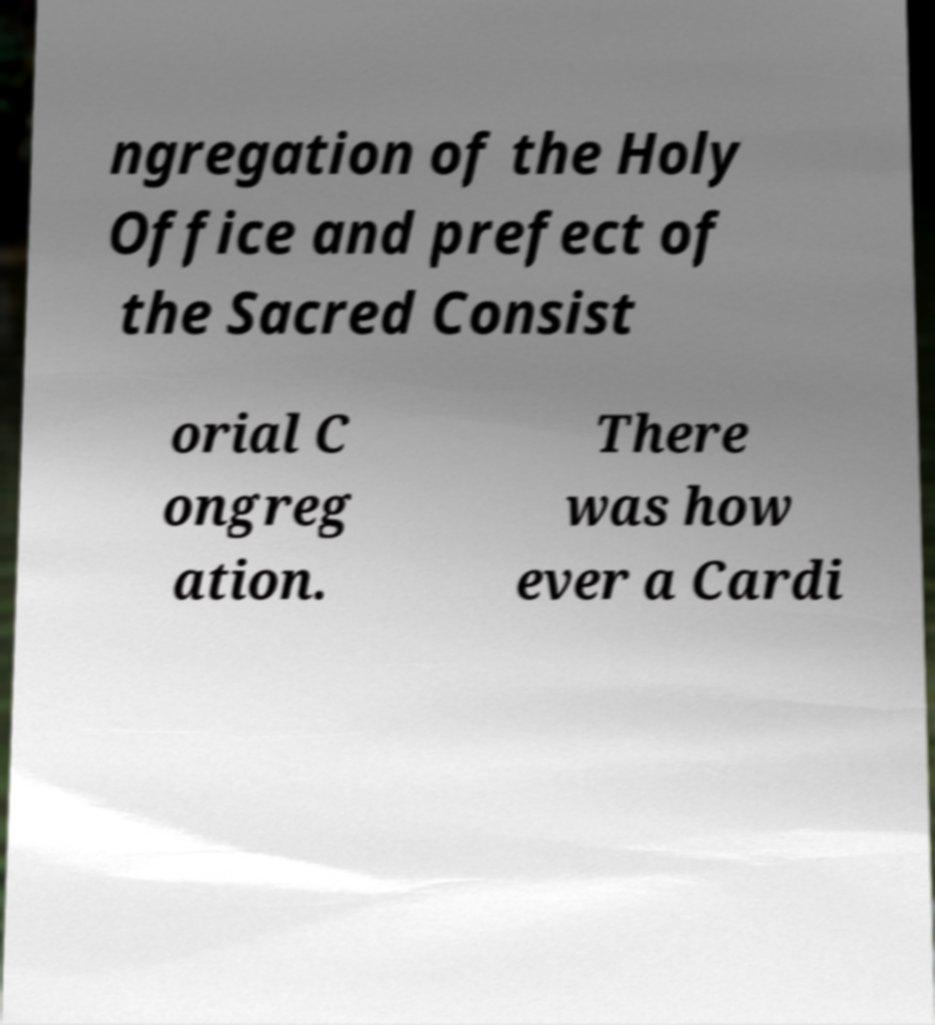Please identify and transcribe the text found in this image. ngregation of the Holy Office and prefect of the Sacred Consist orial C ongreg ation. There was how ever a Cardi 